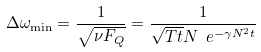<formula> <loc_0><loc_0><loc_500><loc_500>\Delta \omega _ { \min } = \frac { 1 } { \sqrt { \nu F _ { Q } } } = \frac { 1 } { \sqrt { T t } N \ e ^ { - \gamma N ^ { 2 } t } }</formula> 